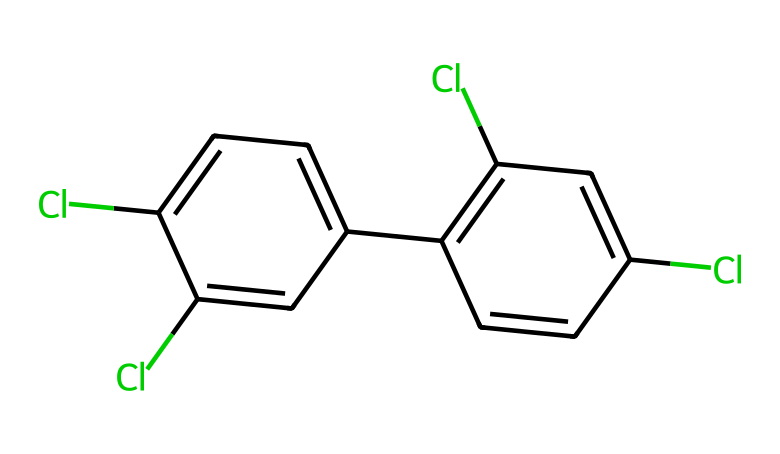What is the full name of this chemical structure? The chemical structure represented by the SMILES code corresponds to polychlorinated biphenyls, which are organic compounds with the formula C12HxCly, where x and y represent the number of hydrogen and chlorine atoms, respectively.
Answer: polychlorinated biphenyls How many chlorine atoms are present? By analyzing the SMILES representation, we can count the 'Cl' symbols. The total count shows 4 chlorine atoms in the structure.
Answer: 4 What type of chemical bond is primarily present in PCBs? The predominant type of bond in polychlorinated biphenyls is the carbon-carbon single bond as well as carbon-chlorine single bonds, which are indicated by the structure's connectivity.
Answer: single bond How many aromatic rings are there in this chemical? The structure reveals two aromatic rings connected to each other, as indicated by overlapping bonds and alternating double bonds, a characteristic of aromatic compounds.
Answer: 2 What is the molecular formula based on the structure? By determining the number of carbons, hydrogens, and chlorines from the structure representation, the molecular formula can be established as C12H4Cl4, with 12 carbon atoms, 4 hydrogen atoms, and 4 chlorine atoms.
Answer: C12H4Cl4 Is this chemical classified as a lubricant? Polychlorinated biphenyls were commonly used as dielectric fluids in electrical equipment but are not classified as lubricants, as they primarily serve other functional roles.
Answer: no What environmental risks are associated with PCBs? PCBs are associated with significant environmental risks including toxicity to aquatic life, bioaccumulation in the food chain, and potential human health risks, often making them hazardous at exposure levels even in low concentrations.
Answer: toxicity 